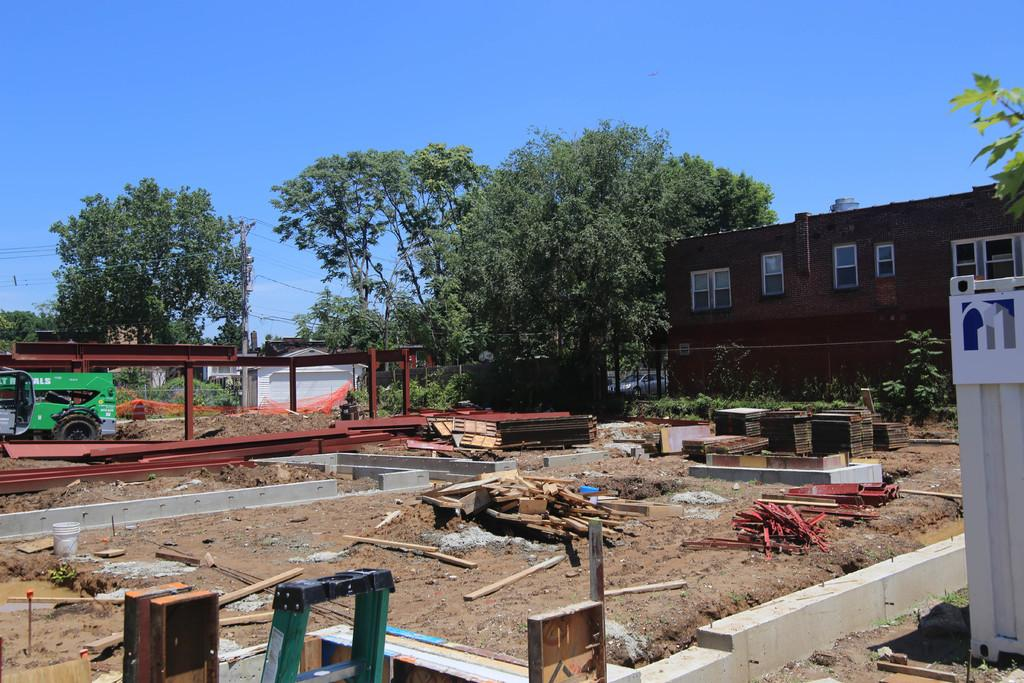What type of structures can be seen in the image? There are houses in the image. What architectural features are present on the houses? There are windows in the image. What type of vegetation is visible in the image? There are plants and trees in the image. What objects are made of wood in the image? There are wooden sticks in the image. What is used for climbing in the image? There is a ladder in the image. What vertical structures are present in the image? There are poles in the image. What mode of transportation is visible in the image? There is a vehicle in the image. What part of the natural environment is visible in the image? The sky is visible in the image. What type of oil can be seen dripping from the vehicle in the image? There is no oil dripping from the vehicle in the image. How many cows are grazing in the image? There are no cows present in the image. 